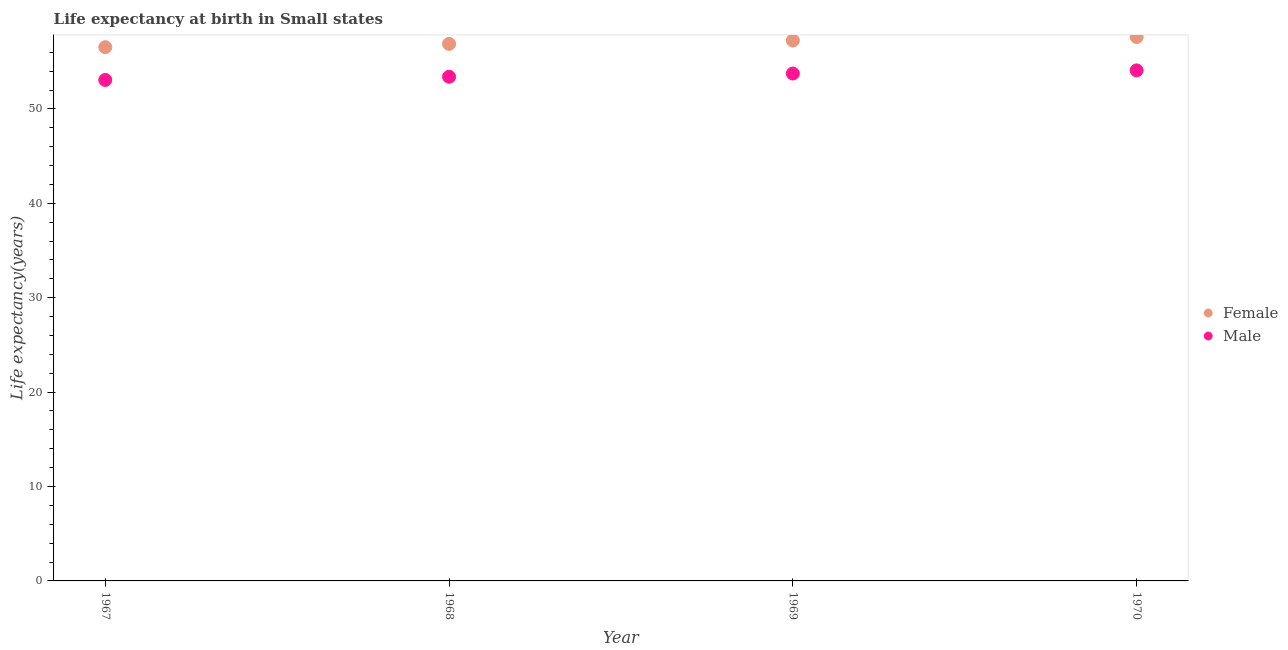What is the life expectancy(female) in 1968?
Keep it short and to the point. 56.89. Across all years, what is the maximum life expectancy(female)?
Offer a terse response. 57.61. Across all years, what is the minimum life expectancy(female)?
Offer a very short reply. 56.53. In which year was the life expectancy(female) minimum?
Offer a very short reply. 1967. What is the total life expectancy(female) in the graph?
Your response must be concise. 228.28. What is the difference between the life expectancy(female) in 1967 and that in 1968?
Your answer should be very brief. -0.35. What is the difference between the life expectancy(female) in 1968 and the life expectancy(male) in 1970?
Your answer should be compact. 2.81. What is the average life expectancy(male) per year?
Give a very brief answer. 53.57. In the year 1968, what is the difference between the life expectancy(male) and life expectancy(female)?
Your answer should be compact. -3.48. What is the ratio of the life expectancy(female) in 1967 to that in 1970?
Your response must be concise. 0.98. Is the difference between the life expectancy(female) in 1967 and 1968 greater than the difference between the life expectancy(male) in 1967 and 1968?
Offer a terse response. No. What is the difference between the highest and the second highest life expectancy(male)?
Your answer should be compact. 0.33. What is the difference between the highest and the lowest life expectancy(male)?
Offer a terse response. 1.02. Is the sum of the life expectancy(male) in 1967 and 1969 greater than the maximum life expectancy(female) across all years?
Your answer should be very brief. Yes. Does the life expectancy(female) monotonically increase over the years?
Your answer should be very brief. Yes. Is the life expectancy(female) strictly greater than the life expectancy(male) over the years?
Provide a short and direct response. Yes. Does the graph contain grids?
Provide a succinct answer. No. Where does the legend appear in the graph?
Your response must be concise. Center right. How are the legend labels stacked?
Make the answer very short. Vertical. What is the title of the graph?
Ensure brevity in your answer.  Life expectancy at birth in Small states. What is the label or title of the Y-axis?
Your answer should be very brief. Life expectancy(years). What is the Life expectancy(years) in Female in 1967?
Your response must be concise. 56.53. What is the Life expectancy(years) in Male in 1967?
Provide a short and direct response. 53.06. What is the Life expectancy(years) of Female in 1968?
Offer a very short reply. 56.89. What is the Life expectancy(years) in Male in 1968?
Your answer should be compact. 53.41. What is the Life expectancy(years) of Female in 1969?
Provide a short and direct response. 57.25. What is the Life expectancy(years) in Male in 1969?
Your answer should be compact. 53.75. What is the Life expectancy(years) in Female in 1970?
Offer a terse response. 57.61. What is the Life expectancy(years) in Male in 1970?
Provide a short and direct response. 54.08. Across all years, what is the maximum Life expectancy(years) of Female?
Offer a very short reply. 57.61. Across all years, what is the maximum Life expectancy(years) in Male?
Your answer should be very brief. 54.08. Across all years, what is the minimum Life expectancy(years) of Female?
Your response must be concise. 56.53. Across all years, what is the minimum Life expectancy(years) in Male?
Offer a terse response. 53.06. What is the total Life expectancy(years) of Female in the graph?
Provide a short and direct response. 228.28. What is the total Life expectancy(years) in Male in the graph?
Your answer should be very brief. 214.29. What is the difference between the Life expectancy(years) of Female in 1967 and that in 1968?
Keep it short and to the point. -0.35. What is the difference between the Life expectancy(years) of Male in 1967 and that in 1968?
Ensure brevity in your answer.  -0.34. What is the difference between the Life expectancy(years) of Female in 1967 and that in 1969?
Provide a succinct answer. -0.71. What is the difference between the Life expectancy(years) of Male in 1967 and that in 1969?
Offer a terse response. -0.68. What is the difference between the Life expectancy(years) in Female in 1967 and that in 1970?
Keep it short and to the point. -1.08. What is the difference between the Life expectancy(years) of Male in 1967 and that in 1970?
Your response must be concise. -1.02. What is the difference between the Life expectancy(years) in Female in 1968 and that in 1969?
Keep it short and to the point. -0.36. What is the difference between the Life expectancy(years) of Male in 1968 and that in 1969?
Give a very brief answer. -0.34. What is the difference between the Life expectancy(years) of Female in 1968 and that in 1970?
Your answer should be compact. -0.73. What is the difference between the Life expectancy(years) in Male in 1968 and that in 1970?
Offer a very short reply. -0.67. What is the difference between the Life expectancy(years) of Female in 1969 and that in 1970?
Your response must be concise. -0.37. What is the difference between the Life expectancy(years) in Male in 1969 and that in 1970?
Your answer should be very brief. -0.33. What is the difference between the Life expectancy(years) of Female in 1967 and the Life expectancy(years) of Male in 1968?
Your answer should be very brief. 3.13. What is the difference between the Life expectancy(years) of Female in 1967 and the Life expectancy(years) of Male in 1969?
Ensure brevity in your answer.  2.79. What is the difference between the Life expectancy(years) in Female in 1967 and the Life expectancy(years) in Male in 1970?
Offer a very short reply. 2.46. What is the difference between the Life expectancy(years) in Female in 1968 and the Life expectancy(years) in Male in 1969?
Ensure brevity in your answer.  3.14. What is the difference between the Life expectancy(years) of Female in 1968 and the Life expectancy(years) of Male in 1970?
Your answer should be very brief. 2.81. What is the difference between the Life expectancy(years) in Female in 1969 and the Life expectancy(years) in Male in 1970?
Offer a terse response. 3.17. What is the average Life expectancy(years) of Female per year?
Give a very brief answer. 57.07. What is the average Life expectancy(years) of Male per year?
Offer a very short reply. 53.57. In the year 1967, what is the difference between the Life expectancy(years) of Female and Life expectancy(years) of Male?
Make the answer very short. 3.47. In the year 1968, what is the difference between the Life expectancy(years) in Female and Life expectancy(years) in Male?
Ensure brevity in your answer.  3.48. In the year 1969, what is the difference between the Life expectancy(years) of Female and Life expectancy(years) of Male?
Ensure brevity in your answer.  3.5. In the year 1970, what is the difference between the Life expectancy(years) in Female and Life expectancy(years) in Male?
Your response must be concise. 3.53. What is the ratio of the Life expectancy(years) in Male in 1967 to that in 1968?
Your response must be concise. 0.99. What is the ratio of the Life expectancy(years) in Female in 1967 to that in 1969?
Your answer should be compact. 0.99. What is the ratio of the Life expectancy(years) of Male in 1967 to that in 1969?
Offer a very short reply. 0.99. What is the ratio of the Life expectancy(years) in Female in 1967 to that in 1970?
Keep it short and to the point. 0.98. What is the ratio of the Life expectancy(years) in Male in 1967 to that in 1970?
Keep it short and to the point. 0.98. What is the ratio of the Life expectancy(years) in Female in 1968 to that in 1969?
Provide a succinct answer. 0.99. What is the ratio of the Life expectancy(years) of Male in 1968 to that in 1969?
Offer a terse response. 0.99. What is the ratio of the Life expectancy(years) in Female in 1968 to that in 1970?
Keep it short and to the point. 0.99. What is the ratio of the Life expectancy(years) in Male in 1968 to that in 1970?
Make the answer very short. 0.99. What is the ratio of the Life expectancy(years) in Female in 1969 to that in 1970?
Offer a terse response. 0.99. What is the difference between the highest and the second highest Life expectancy(years) in Female?
Ensure brevity in your answer.  0.37. What is the difference between the highest and the second highest Life expectancy(years) of Male?
Keep it short and to the point. 0.33. What is the difference between the highest and the lowest Life expectancy(years) in Female?
Make the answer very short. 1.08. What is the difference between the highest and the lowest Life expectancy(years) of Male?
Keep it short and to the point. 1.02. 